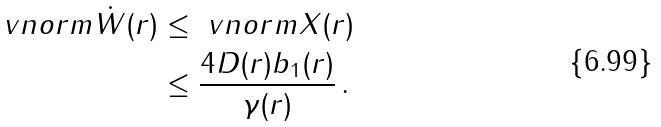<formula> <loc_0><loc_0><loc_500><loc_500>\ v n o r m { \dot { W } ( r ) } & \leq \ v n o r m { X ( r ) } \\ & \leq \frac { 4 D ( r ) b _ { 1 } ( r ) } { \gamma ( r ) } \, .</formula> 